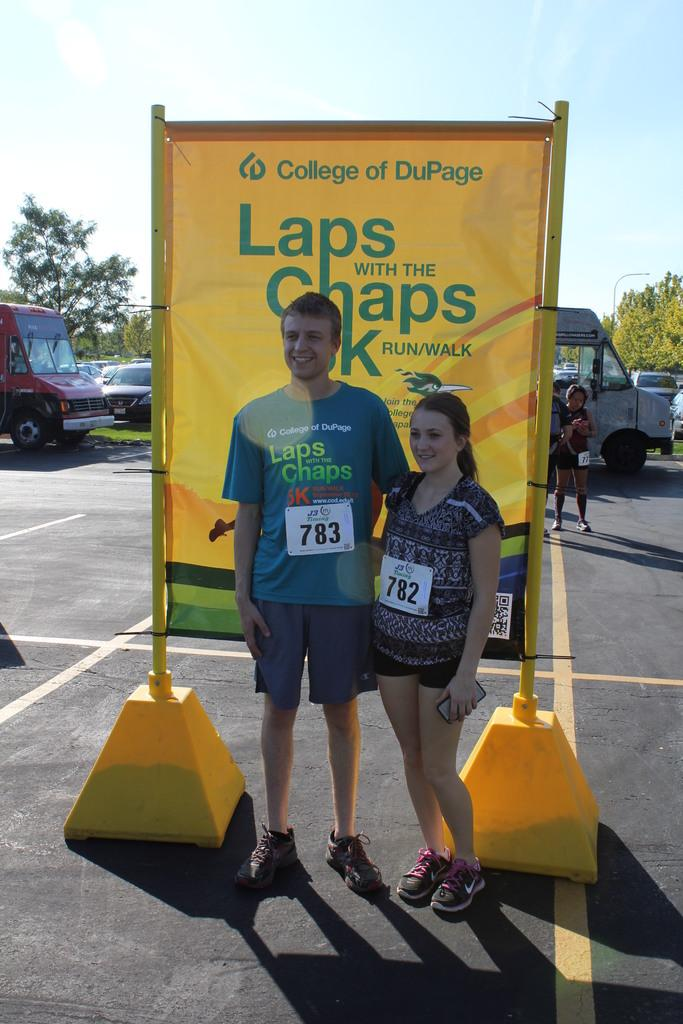Who is present in the image? There is a man and a woman in the image. What are the man and woman doing in the image? The man and woman are posing for a camera and smiling. What else can be seen in the image besides the man and woman? There are vehicles, trees, a banner, and a person visible in the image. What is visible in the background of the image? The sky is visible in the background of the image. How many fish can be seen swimming in the image? There are no fish present in the image. What direction is the van turning in the image? There is no van present in the image. 